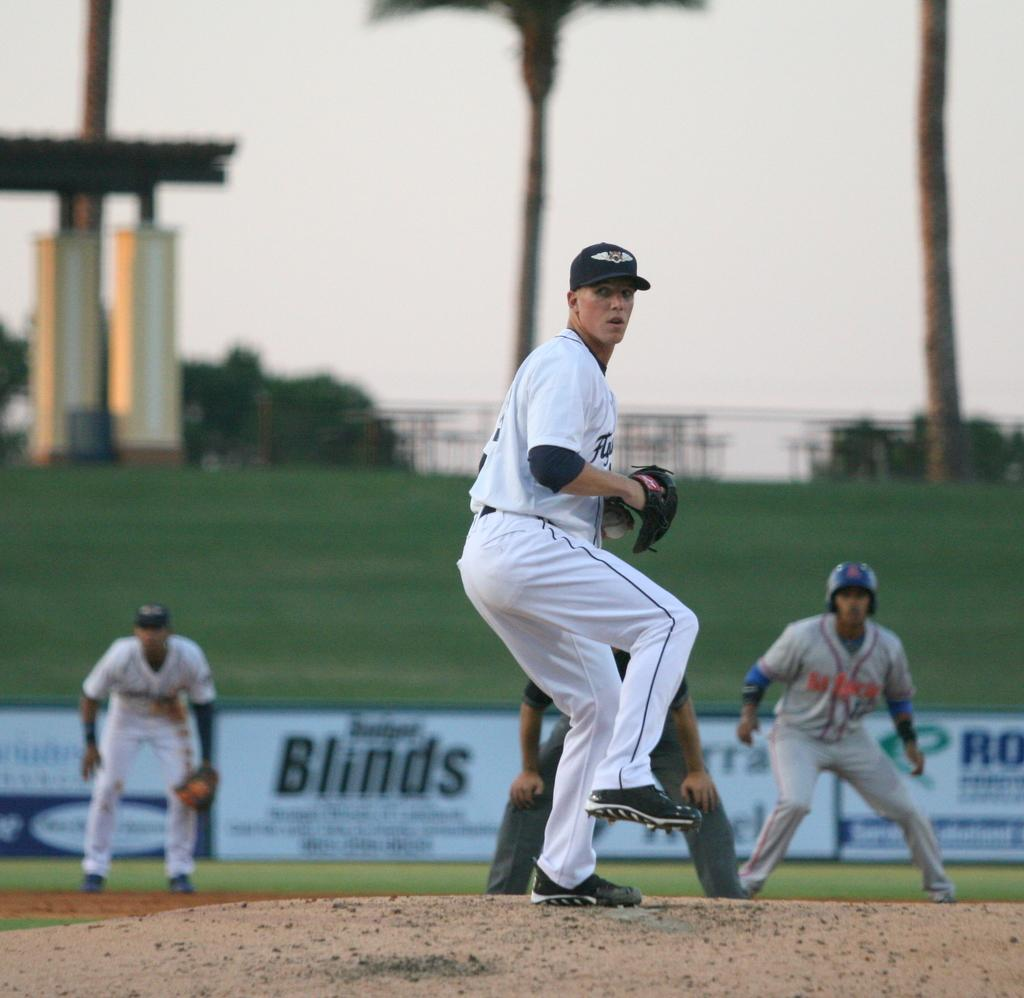<image>
Create a compact narrative representing the image presented. A pitcher on the mound during a baseball game that is sponsored by a Blinds company. 